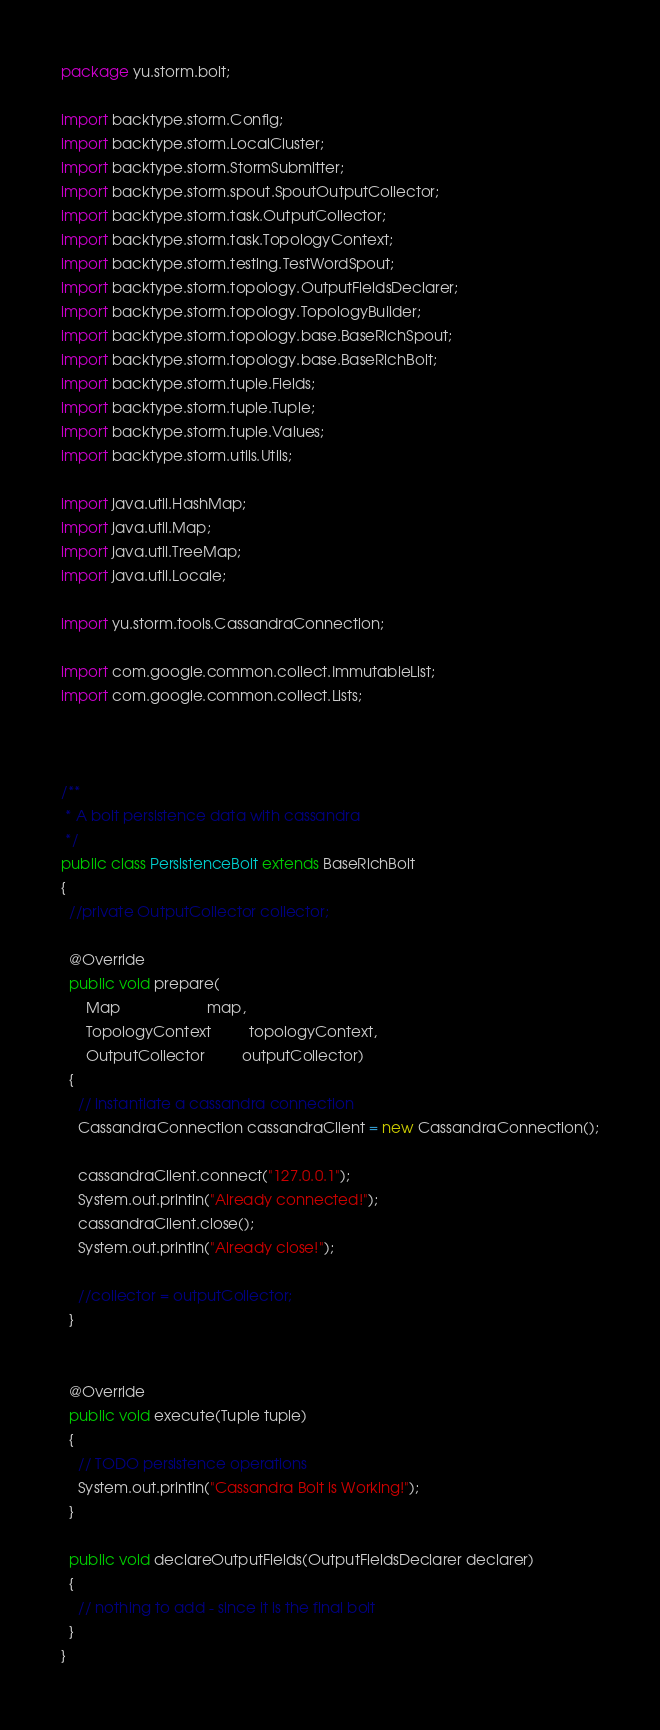<code> <loc_0><loc_0><loc_500><loc_500><_Java_>package yu.storm.bolt;

import backtype.storm.Config;
import backtype.storm.LocalCluster;
import backtype.storm.StormSubmitter;
import backtype.storm.spout.SpoutOutputCollector;
import backtype.storm.task.OutputCollector;
import backtype.storm.task.TopologyContext;
import backtype.storm.testing.TestWordSpout;
import backtype.storm.topology.OutputFieldsDeclarer;
import backtype.storm.topology.TopologyBuilder;
import backtype.storm.topology.base.BaseRichSpout;
import backtype.storm.topology.base.BaseRichBolt;
import backtype.storm.tuple.Fields;
import backtype.storm.tuple.Tuple;
import backtype.storm.tuple.Values;
import backtype.storm.utils.Utils;

import java.util.HashMap;
import java.util.Map;
import java.util.TreeMap;
import java.util.Locale;

import yu.storm.tools.CassandraConnection;

import com.google.common.collect.ImmutableList;
import com.google.common.collect.Lists;



/**
 * A bolt persistence data with cassandra
 */
public class PersistenceBolt extends BaseRichBolt
{
  //private OutputCollector collector;

  @Override
  public void prepare(
      Map                     map,
      TopologyContext         topologyContext,
      OutputCollector         outputCollector)
  {
    // instantiate a cassandra connection
    CassandraConnection cassandraClient = new CassandraConnection();
    
    cassandraClient.connect("127.0.0.1");
    System.out.println("Already connected!");
    cassandraClient.close();
    System.out.println("Already close!");
    
    //collector = outputCollector;
  }


  @Override
  public void execute(Tuple tuple)
  {
    // TODO persistence operations
    System.out.println("Cassandra Bolt is Working!");
  }

  public void declareOutputFields(OutputFieldsDeclarer declarer)
  {
    // nothing to add - since it is the final bolt
  }
}
</code> 